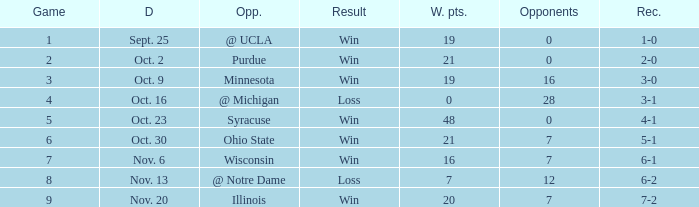How many wins or losses were there when the record was 3-0? 1.0. 